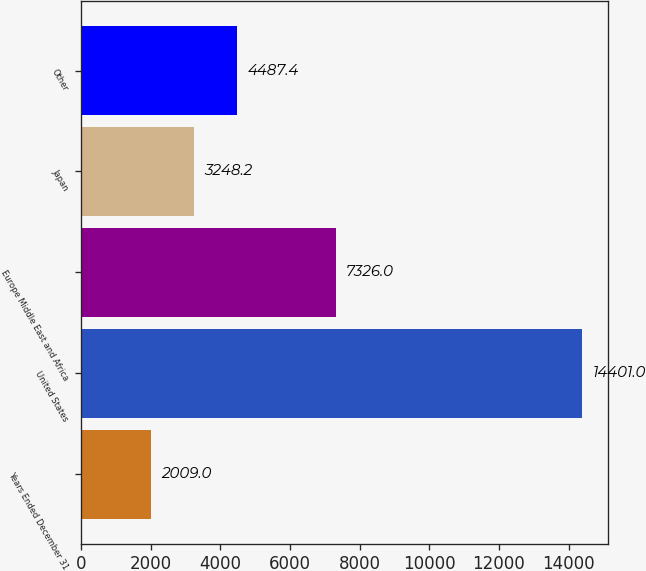Convert chart to OTSL. <chart><loc_0><loc_0><loc_500><loc_500><bar_chart><fcel>Years Ended December 31<fcel>United States<fcel>Europe Middle East and Africa<fcel>Japan<fcel>Other<nl><fcel>2009<fcel>14401<fcel>7326<fcel>3248.2<fcel>4487.4<nl></chart> 